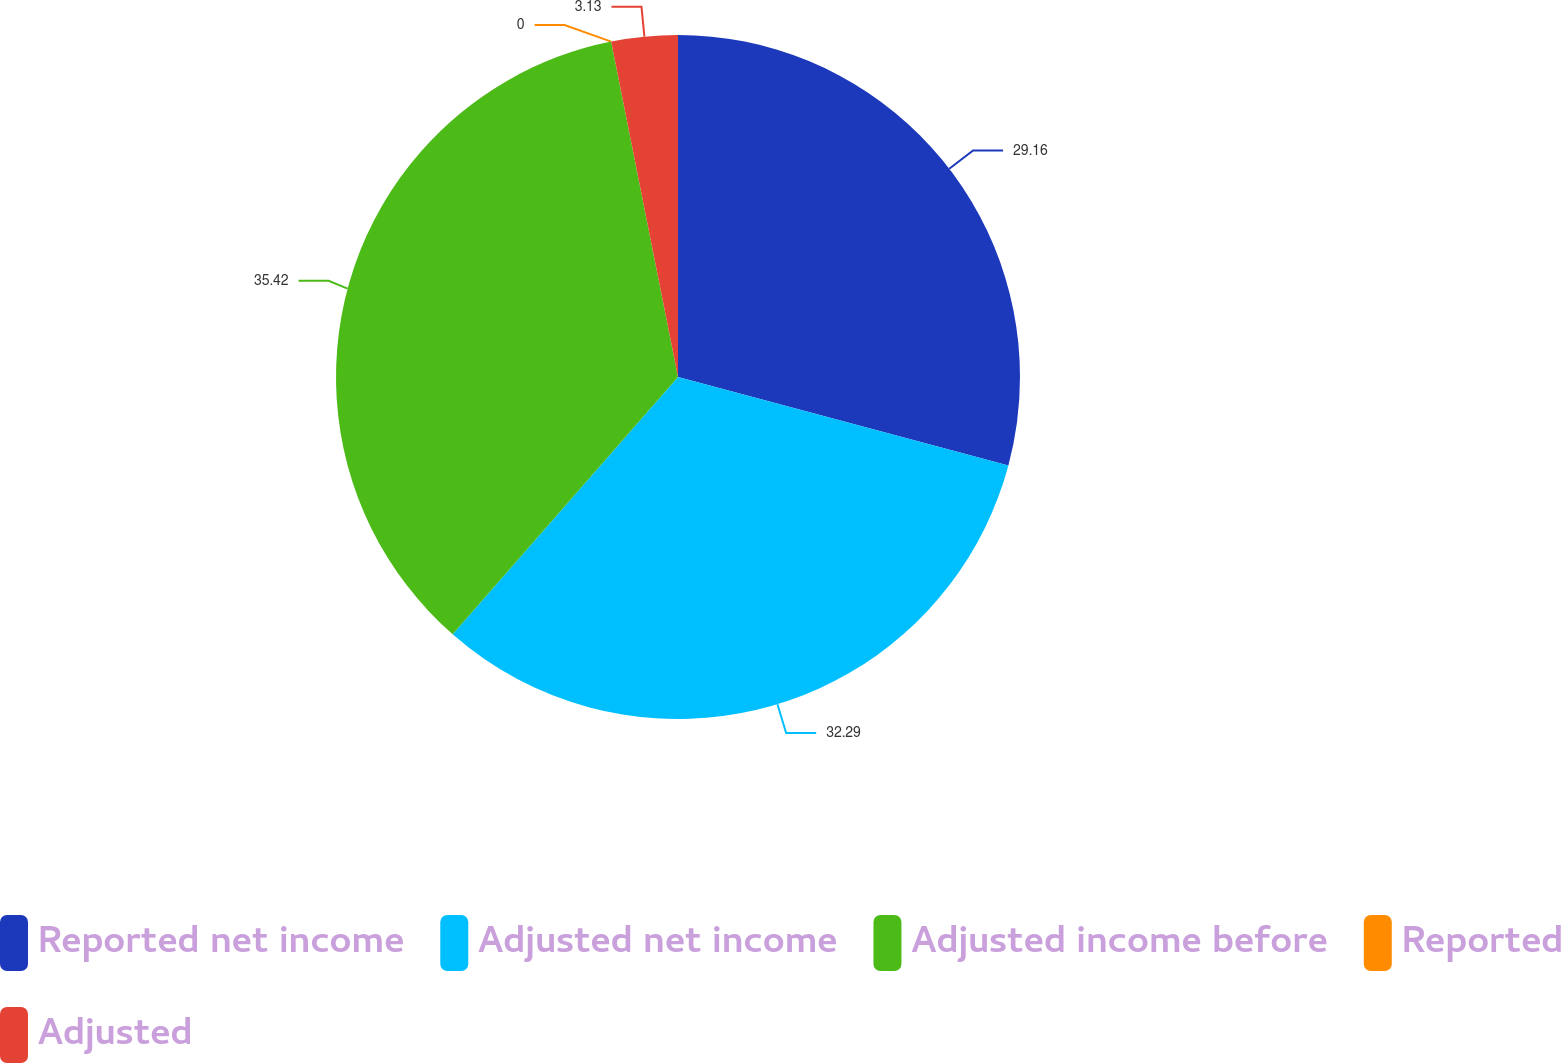Convert chart to OTSL. <chart><loc_0><loc_0><loc_500><loc_500><pie_chart><fcel>Reported net income<fcel>Adjusted net income<fcel>Adjusted income before<fcel>Reported<fcel>Adjusted<nl><fcel>29.16%<fcel>32.29%<fcel>35.42%<fcel>0.0%<fcel>3.13%<nl></chart> 